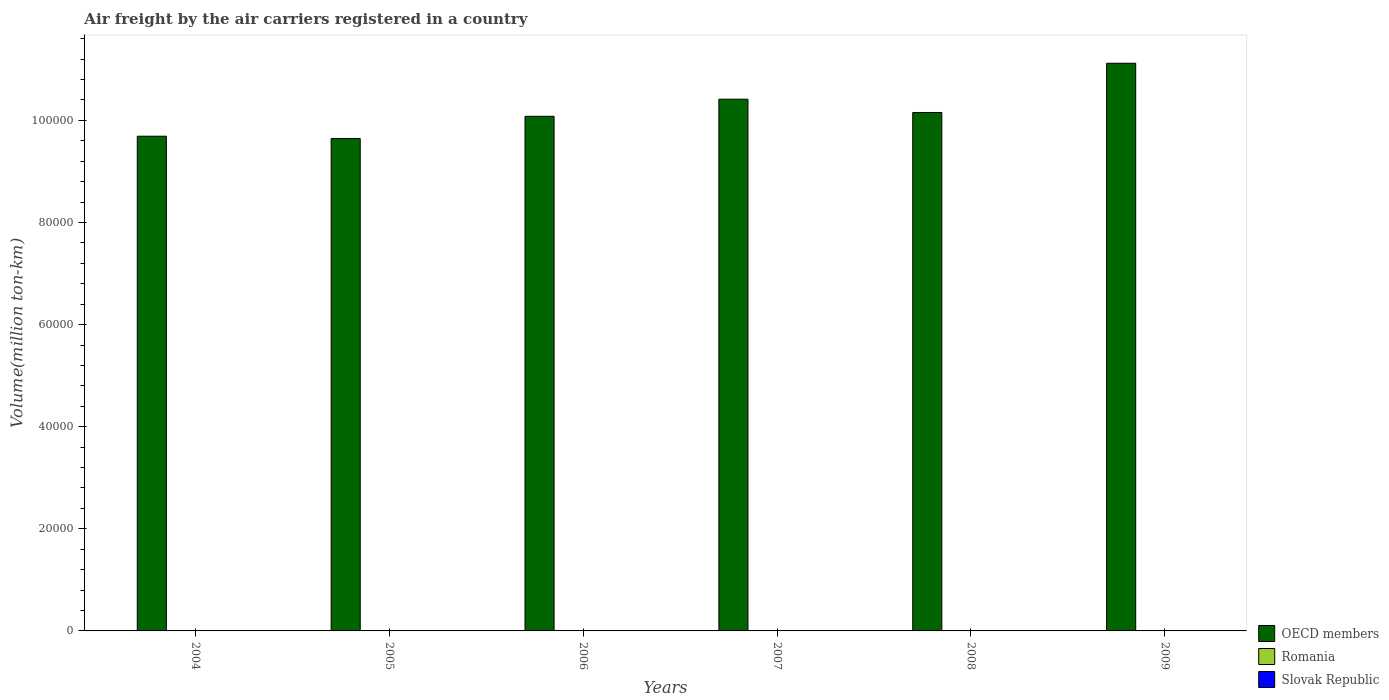How many different coloured bars are there?
Provide a short and direct response. 3. Are the number of bars per tick equal to the number of legend labels?
Offer a very short reply. Yes. How many bars are there on the 5th tick from the left?
Offer a terse response. 3. What is the label of the 3rd group of bars from the left?
Ensure brevity in your answer.  2006. In how many cases, is the number of bars for a given year not equal to the number of legend labels?
Offer a terse response. 0. What is the volume of the air carriers in Slovak Republic in 2005?
Offer a terse response. 0.32. Across all years, what is the maximum volume of the air carriers in Slovak Republic?
Offer a terse response. 45.91. Across all years, what is the minimum volume of the air carriers in Romania?
Make the answer very short. 3.99. What is the total volume of the air carriers in Romania in the graph?
Your response must be concise. 31.12. What is the difference between the volume of the air carriers in Romania in 2004 and that in 2007?
Give a very brief answer. -0.8. What is the difference between the volume of the air carriers in OECD members in 2008 and the volume of the air carriers in Romania in 2006?
Make the answer very short. 1.02e+05. What is the average volume of the air carriers in Slovak Republic per year?
Give a very brief answer. 15.46. In the year 2007, what is the difference between the volume of the air carriers in Romania and volume of the air carriers in OECD members?
Offer a very short reply. -1.04e+05. What is the ratio of the volume of the air carriers in OECD members in 2007 to that in 2009?
Provide a succinct answer. 0.94. What is the difference between the highest and the second highest volume of the air carriers in Romania?
Provide a short and direct response. 0.74. What is the difference between the highest and the lowest volume of the air carriers in OECD members?
Give a very brief answer. 1.47e+04. In how many years, is the volume of the air carriers in Slovak Republic greater than the average volume of the air carriers in Slovak Republic taken over all years?
Provide a short and direct response. 2. What does the 2nd bar from the left in 2009 represents?
Offer a very short reply. Romania. How many years are there in the graph?
Offer a very short reply. 6. Are the values on the major ticks of Y-axis written in scientific E-notation?
Keep it short and to the point. No. Does the graph contain any zero values?
Offer a terse response. No. Does the graph contain grids?
Provide a succinct answer. No. Where does the legend appear in the graph?
Offer a terse response. Bottom right. How many legend labels are there?
Make the answer very short. 3. How are the legend labels stacked?
Make the answer very short. Vertical. What is the title of the graph?
Offer a very short reply. Air freight by the air carriers registered in a country. What is the label or title of the Y-axis?
Your answer should be compact. Volume(million ton-km). What is the Volume(million ton-km) of OECD members in 2004?
Offer a terse response. 9.69e+04. What is the Volume(million ton-km) of Romania in 2004?
Keep it short and to the point. 4.88. What is the Volume(million ton-km) of Slovak Republic in 2004?
Offer a very short reply. 0.5. What is the Volume(million ton-km) in OECD members in 2005?
Your answer should be compact. 9.65e+04. What is the Volume(million ton-km) in Romania in 2005?
Keep it short and to the point. 5.16. What is the Volume(million ton-km) in Slovak Republic in 2005?
Your answer should be very brief. 0.32. What is the Volume(million ton-km) in OECD members in 2006?
Give a very brief answer. 1.01e+05. What is the Volume(million ton-km) in Romania in 2006?
Provide a short and direct response. 4.98. What is the Volume(million ton-km) of Slovak Republic in 2006?
Give a very brief answer. 0.3. What is the Volume(million ton-km) in OECD members in 2007?
Make the answer very short. 1.04e+05. What is the Volume(million ton-km) in Romania in 2007?
Make the answer very short. 5.68. What is the Volume(million ton-km) of Slovak Republic in 2007?
Provide a short and direct response. 45.48. What is the Volume(million ton-km) of OECD members in 2008?
Ensure brevity in your answer.  1.02e+05. What is the Volume(million ton-km) in Romania in 2008?
Keep it short and to the point. 6.42. What is the Volume(million ton-km) in Slovak Republic in 2008?
Keep it short and to the point. 45.91. What is the Volume(million ton-km) of OECD members in 2009?
Keep it short and to the point. 1.11e+05. What is the Volume(million ton-km) of Romania in 2009?
Give a very brief answer. 3.99. What is the Volume(million ton-km) in Slovak Republic in 2009?
Provide a short and direct response. 0.23. Across all years, what is the maximum Volume(million ton-km) in OECD members?
Offer a terse response. 1.11e+05. Across all years, what is the maximum Volume(million ton-km) of Romania?
Offer a very short reply. 6.42. Across all years, what is the maximum Volume(million ton-km) of Slovak Republic?
Offer a very short reply. 45.91. Across all years, what is the minimum Volume(million ton-km) of OECD members?
Your answer should be very brief. 9.65e+04. Across all years, what is the minimum Volume(million ton-km) in Romania?
Your answer should be very brief. 3.99. Across all years, what is the minimum Volume(million ton-km) of Slovak Republic?
Make the answer very short. 0.23. What is the total Volume(million ton-km) in OECD members in the graph?
Keep it short and to the point. 6.11e+05. What is the total Volume(million ton-km) in Romania in the graph?
Ensure brevity in your answer.  31.12. What is the total Volume(million ton-km) in Slovak Republic in the graph?
Provide a succinct answer. 92.74. What is the difference between the Volume(million ton-km) in OECD members in 2004 and that in 2005?
Keep it short and to the point. 447.78. What is the difference between the Volume(million ton-km) of Romania in 2004 and that in 2005?
Provide a succinct answer. -0.28. What is the difference between the Volume(million ton-km) in Slovak Republic in 2004 and that in 2005?
Offer a terse response. 0.19. What is the difference between the Volume(million ton-km) in OECD members in 2004 and that in 2006?
Your answer should be compact. -3902.39. What is the difference between the Volume(million ton-km) of Romania in 2004 and that in 2006?
Keep it short and to the point. -0.1. What is the difference between the Volume(million ton-km) of Slovak Republic in 2004 and that in 2006?
Your response must be concise. 0.2. What is the difference between the Volume(million ton-km) of OECD members in 2004 and that in 2007?
Provide a succinct answer. -7248.76. What is the difference between the Volume(million ton-km) of Romania in 2004 and that in 2007?
Your answer should be compact. -0.8. What is the difference between the Volume(million ton-km) in Slovak Republic in 2004 and that in 2007?
Provide a short and direct response. -44.98. What is the difference between the Volume(million ton-km) of OECD members in 2004 and that in 2008?
Give a very brief answer. -4643.08. What is the difference between the Volume(million ton-km) of Romania in 2004 and that in 2008?
Make the answer very short. -1.54. What is the difference between the Volume(million ton-km) in Slovak Republic in 2004 and that in 2008?
Offer a terse response. -45.41. What is the difference between the Volume(million ton-km) in OECD members in 2004 and that in 2009?
Ensure brevity in your answer.  -1.43e+04. What is the difference between the Volume(million ton-km) in Romania in 2004 and that in 2009?
Provide a succinct answer. 0.89. What is the difference between the Volume(million ton-km) of Slovak Republic in 2004 and that in 2009?
Offer a terse response. 0.28. What is the difference between the Volume(million ton-km) of OECD members in 2005 and that in 2006?
Provide a succinct answer. -4350.16. What is the difference between the Volume(million ton-km) of Romania in 2005 and that in 2006?
Offer a terse response. 0.18. What is the difference between the Volume(million ton-km) of Slovak Republic in 2005 and that in 2006?
Your answer should be compact. 0.01. What is the difference between the Volume(million ton-km) of OECD members in 2005 and that in 2007?
Your answer should be compact. -7696.53. What is the difference between the Volume(million ton-km) in Romania in 2005 and that in 2007?
Your answer should be compact. -0.52. What is the difference between the Volume(million ton-km) of Slovak Republic in 2005 and that in 2007?
Make the answer very short. -45.17. What is the difference between the Volume(million ton-km) in OECD members in 2005 and that in 2008?
Provide a succinct answer. -5090.85. What is the difference between the Volume(million ton-km) of Romania in 2005 and that in 2008?
Keep it short and to the point. -1.26. What is the difference between the Volume(million ton-km) in Slovak Republic in 2005 and that in 2008?
Your answer should be very brief. -45.59. What is the difference between the Volume(million ton-km) of OECD members in 2005 and that in 2009?
Offer a very short reply. -1.47e+04. What is the difference between the Volume(million ton-km) in Romania in 2005 and that in 2009?
Your response must be concise. 1.17. What is the difference between the Volume(million ton-km) of Slovak Republic in 2005 and that in 2009?
Your answer should be very brief. 0.09. What is the difference between the Volume(million ton-km) in OECD members in 2006 and that in 2007?
Your answer should be compact. -3346.37. What is the difference between the Volume(million ton-km) of Slovak Republic in 2006 and that in 2007?
Your answer should be very brief. -45.18. What is the difference between the Volume(million ton-km) of OECD members in 2006 and that in 2008?
Provide a succinct answer. -740.69. What is the difference between the Volume(million ton-km) in Romania in 2006 and that in 2008?
Your answer should be compact. -1.44. What is the difference between the Volume(million ton-km) of Slovak Republic in 2006 and that in 2008?
Provide a succinct answer. -45.61. What is the difference between the Volume(million ton-km) in OECD members in 2006 and that in 2009?
Provide a short and direct response. -1.04e+04. What is the difference between the Volume(million ton-km) of Slovak Republic in 2006 and that in 2009?
Keep it short and to the point. 0.08. What is the difference between the Volume(million ton-km) of OECD members in 2007 and that in 2008?
Provide a succinct answer. 2605.68. What is the difference between the Volume(million ton-km) of Romania in 2007 and that in 2008?
Provide a short and direct response. -0.74. What is the difference between the Volume(million ton-km) of Slovak Republic in 2007 and that in 2008?
Make the answer very short. -0.42. What is the difference between the Volume(million ton-km) in OECD members in 2007 and that in 2009?
Give a very brief answer. -7039.77. What is the difference between the Volume(million ton-km) in Romania in 2007 and that in 2009?
Give a very brief answer. 1.7. What is the difference between the Volume(million ton-km) of Slovak Republic in 2007 and that in 2009?
Your answer should be very brief. 45.26. What is the difference between the Volume(million ton-km) in OECD members in 2008 and that in 2009?
Ensure brevity in your answer.  -9645.46. What is the difference between the Volume(million ton-km) in Romania in 2008 and that in 2009?
Give a very brief answer. 2.43. What is the difference between the Volume(million ton-km) in Slovak Republic in 2008 and that in 2009?
Give a very brief answer. 45.69. What is the difference between the Volume(million ton-km) in OECD members in 2004 and the Volume(million ton-km) in Romania in 2005?
Make the answer very short. 9.69e+04. What is the difference between the Volume(million ton-km) in OECD members in 2004 and the Volume(million ton-km) in Slovak Republic in 2005?
Your response must be concise. 9.69e+04. What is the difference between the Volume(million ton-km) in Romania in 2004 and the Volume(million ton-km) in Slovak Republic in 2005?
Make the answer very short. 4.56. What is the difference between the Volume(million ton-km) in OECD members in 2004 and the Volume(million ton-km) in Romania in 2006?
Offer a terse response. 9.69e+04. What is the difference between the Volume(million ton-km) in OECD members in 2004 and the Volume(million ton-km) in Slovak Republic in 2006?
Ensure brevity in your answer.  9.69e+04. What is the difference between the Volume(million ton-km) in Romania in 2004 and the Volume(million ton-km) in Slovak Republic in 2006?
Your answer should be compact. 4.58. What is the difference between the Volume(million ton-km) in OECD members in 2004 and the Volume(million ton-km) in Romania in 2007?
Keep it short and to the point. 9.69e+04. What is the difference between the Volume(million ton-km) of OECD members in 2004 and the Volume(million ton-km) of Slovak Republic in 2007?
Offer a very short reply. 9.69e+04. What is the difference between the Volume(million ton-km) in Romania in 2004 and the Volume(million ton-km) in Slovak Republic in 2007?
Your response must be concise. -40.6. What is the difference between the Volume(million ton-km) in OECD members in 2004 and the Volume(million ton-km) in Romania in 2008?
Ensure brevity in your answer.  9.69e+04. What is the difference between the Volume(million ton-km) of OECD members in 2004 and the Volume(million ton-km) of Slovak Republic in 2008?
Keep it short and to the point. 9.69e+04. What is the difference between the Volume(million ton-km) in Romania in 2004 and the Volume(million ton-km) in Slovak Republic in 2008?
Your response must be concise. -41.03. What is the difference between the Volume(million ton-km) in OECD members in 2004 and the Volume(million ton-km) in Romania in 2009?
Ensure brevity in your answer.  9.69e+04. What is the difference between the Volume(million ton-km) in OECD members in 2004 and the Volume(million ton-km) in Slovak Republic in 2009?
Offer a very short reply. 9.69e+04. What is the difference between the Volume(million ton-km) in Romania in 2004 and the Volume(million ton-km) in Slovak Republic in 2009?
Your response must be concise. 4.66. What is the difference between the Volume(million ton-km) of OECD members in 2005 and the Volume(million ton-km) of Romania in 2006?
Provide a short and direct response. 9.65e+04. What is the difference between the Volume(million ton-km) of OECD members in 2005 and the Volume(million ton-km) of Slovak Republic in 2006?
Provide a succinct answer. 9.65e+04. What is the difference between the Volume(million ton-km) of Romania in 2005 and the Volume(million ton-km) of Slovak Republic in 2006?
Ensure brevity in your answer.  4.86. What is the difference between the Volume(million ton-km) of OECD members in 2005 and the Volume(million ton-km) of Romania in 2007?
Offer a terse response. 9.65e+04. What is the difference between the Volume(million ton-km) in OECD members in 2005 and the Volume(million ton-km) in Slovak Republic in 2007?
Your answer should be compact. 9.64e+04. What is the difference between the Volume(million ton-km) of Romania in 2005 and the Volume(million ton-km) of Slovak Republic in 2007?
Provide a succinct answer. -40.32. What is the difference between the Volume(million ton-km) of OECD members in 2005 and the Volume(million ton-km) of Romania in 2008?
Make the answer very short. 9.65e+04. What is the difference between the Volume(million ton-km) of OECD members in 2005 and the Volume(million ton-km) of Slovak Republic in 2008?
Your answer should be compact. 9.64e+04. What is the difference between the Volume(million ton-km) of Romania in 2005 and the Volume(million ton-km) of Slovak Republic in 2008?
Your answer should be very brief. -40.75. What is the difference between the Volume(million ton-km) of OECD members in 2005 and the Volume(million ton-km) of Romania in 2009?
Offer a terse response. 9.65e+04. What is the difference between the Volume(million ton-km) in OECD members in 2005 and the Volume(million ton-km) in Slovak Republic in 2009?
Your response must be concise. 9.65e+04. What is the difference between the Volume(million ton-km) of Romania in 2005 and the Volume(million ton-km) of Slovak Republic in 2009?
Provide a succinct answer. 4.94. What is the difference between the Volume(million ton-km) of OECD members in 2006 and the Volume(million ton-km) of Romania in 2007?
Offer a terse response. 1.01e+05. What is the difference between the Volume(million ton-km) of OECD members in 2006 and the Volume(million ton-km) of Slovak Republic in 2007?
Your answer should be compact. 1.01e+05. What is the difference between the Volume(million ton-km) of Romania in 2006 and the Volume(million ton-km) of Slovak Republic in 2007?
Provide a succinct answer. -40.5. What is the difference between the Volume(million ton-km) in OECD members in 2006 and the Volume(million ton-km) in Romania in 2008?
Your response must be concise. 1.01e+05. What is the difference between the Volume(million ton-km) of OECD members in 2006 and the Volume(million ton-km) of Slovak Republic in 2008?
Your answer should be compact. 1.01e+05. What is the difference between the Volume(million ton-km) of Romania in 2006 and the Volume(million ton-km) of Slovak Republic in 2008?
Ensure brevity in your answer.  -40.93. What is the difference between the Volume(million ton-km) of OECD members in 2006 and the Volume(million ton-km) of Romania in 2009?
Provide a short and direct response. 1.01e+05. What is the difference between the Volume(million ton-km) of OECD members in 2006 and the Volume(million ton-km) of Slovak Republic in 2009?
Your answer should be compact. 1.01e+05. What is the difference between the Volume(million ton-km) in Romania in 2006 and the Volume(million ton-km) in Slovak Republic in 2009?
Offer a very short reply. 4.76. What is the difference between the Volume(million ton-km) in OECD members in 2007 and the Volume(million ton-km) in Romania in 2008?
Keep it short and to the point. 1.04e+05. What is the difference between the Volume(million ton-km) of OECD members in 2007 and the Volume(million ton-km) of Slovak Republic in 2008?
Your answer should be very brief. 1.04e+05. What is the difference between the Volume(million ton-km) of Romania in 2007 and the Volume(million ton-km) of Slovak Republic in 2008?
Make the answer very short. -40.23. What is the difference between the Volume(million ton-km) of OECD members in 2007 and the Volume(million ton-km) of Romania in 2009?
Offer a very short reply. 1.04e+05. What is the difference between the Volume(million ton-km) of OECD members in 2007 and the Volume(million ton-km) of Slovak Republic in 2009?
Provide a short and direct response. 1.04e+05. What is the difference between the Volume(million ton-km) of Romania in 2007 and the Volume(million ton-km) of Slovak Republic in 2009?
Keep it short and to the point. 5.46. What is the difference between the Volume(million ton-km) of OECD members in 2008 and the Volume(million ton-km) of Romania in 2009?
Your answer should be compact. 1.02e+05. What is the difference between the Volume(million ton-km) of OECD members in 2008 and the Volume(million ton-km) of Slovak Republic in 2009?
Provide a short and direct response. 1.02e+05. What is the difference between the Volume(million ton-km) of Romania in 2008 and the Volume(million ton-km) of Slovak Republic in 2009?
Provide a short and direct response. 6.2. What is the average Volume(million ton-km) of OECD members per year?
Provide a short and direct response. 1.02e+05. What is the average Volume(million ton-km) in Romania per year?
Your answer should be very brief. 5.19. What is the average Volume(million ton-km) in Slovak Republic per year?
Ensure brevity in your answer.  15.46. In the year 2004, what is the difference between the Volume(million ton-km) in OECD members and Volume(million ton-km) in Romania?
Make the answer very short. 9.69e+04. In the year 2004, what is the difference between the Volume(million ton-km) in OECD members and Volume(million ton-km) in Slovak Republic?
Offer a very short reply. 9.69e+04. In the year 2004, what is the difference between the Volume(million ton-km) of Romania and Volume(million ton-km) of Slovak Republic?
Give a very brief answer. 4.38. In the year 2005, what is the difference between the Volume(million ton-km) of OECD members and Volume(million ton-km) of Romania?
Provide a short and direct response. 9.65e+04. In the year 2005, what is the difference between the Volume(million ton-km) in OECD members and Volume(million ton-km) in Slovak Republic?
Ensure brevity in your answer.  9.65e+04. In the year 2005, what is the difference between the Volume(million ton-km) of Romania and Volume(million ton-km) of Slovak Republic?
Ensure brevity in your answer.  4.84. In the year 2006, what is the difference between the Volume(million ton-km) in OECD members and Volume(million ton-km) in Romania?
Ensure brevity in your answer.  1.01e+05. In the year 2006, what is the difference between the Volume(million ton-km) of OECD members and Volume(million ton-km) of Slovak Republic?
Your answer should be very brief. 1.01e+05. In the year 2006, what is the difference between the Volume(million ton-km) in Romania and Volume(million ton-km) in Slovak Republic?
Your answer should be very brief. 4.68. In the year 2007, what is the difference between the Volume(million ton-km) of OECD members and Volume(million ton-km) of Romania?
Keep it short and to the point. 1.04e+05. In the year 2007, what is the difference between the Volume(million ton-km) of OECD members and Volume(million ton-km) of Slovak Republic?
Provide a short and direct response. 1.04e+05. In the year 2007, what is the difference between the Volume(million ton-km) of Romania and Volume(million ton-km) of Slovak Republic?
Keep it short and to the point. -39.8. In the year 2008, what is the difference between the Volume(million ton-km) of OECD members and Volume(million ton-km) of Romania?
Ensure brevity in your answer.  1.02e+05. In the year 2008, what is the difference between the Volume(million ton-km) of OECD members and Volume(million ton-km) of Slovak Republic?
Keep it short and to the point. 1.02e+05. In the year 2008, what is the difference between the Volume(million ton-km) in Romania and Volume(million ton-km) in Slovak Republic?
Provide a short and direct response. -39.49. In the year 2009, what is the difference between the Volume(million ton-km) in OECD members and Volume(million ton-km) in Romania?
Ensure brevity in your answer.  1.11e+05. In the year 2009, what is the difference between the Volume(million ton-km) of OECD members and Volume(million ton-km) of Slovak Republic?
Provide a succinct answer. 1.11e+05. In the year 2009, what is the difference between the Volume(million ton-km) of Romania and Volume(million ton-km) of Slovak Republic?
Offer a very short reply. 3.76. What is the ratio of the Volume(million ton-km) in Romania in 2004 to that in 2005?
Provide a short and direct response. 0.95. What is the ratio of the Volume(million ton-km) in Slovak Republic in 2004 to that in 2005?
Provide a succinct answer. 1.59. What is the ratio of the Volume(million ton-km) in OECD members in 2004 to that in 2006?
Make the answer very short. 0.96. What is the ratio of the Volume(million ton-km) of Romania in 2004 to that in 2006?
Offer a terse response. 0.98. What is the ratio of the Volume(million ton-km) in Slovak Republic in 2004 to that in 2006?
Ensure brevity in your answer.  1.67. What is the ratio of the Volume(million ton-km) of OECD members in 2004 to that in 2007?
Make the answer very short. 0.93. What is the ratio of the Volume(million ton-km) of Romania in 2004 to that in 2007?
Offer a very short reply. 0.86. What is the ratio of the Volume(million ton-km) of Slovak Republic in 2004 to that in 2007?
Offer a terse response. 0.01. What is the ratio of the Volume(million ton-km) of OECD members in 2004 to that in 2008?
Provide a short and direct response. 0.95. What is the ratio of the Volume(million ton-km) in Romania in 2004 to that in 2008?
Your answer should be very brief. 0.76. What is the ratio of the Volume(million ton-km) of Slovak Republic in 2004 to that in 2008?
Provide a succinct answer. 0.01. What is the ratio of the Volume(million ton-km) of OECD members in 2004 to that in 2009?
Provide a short and direct response. 0.87. What is the ratio of the Volume(million ton-km) of Romania in 2004 to that in 2009?
Your answer should be very brief. 1.22. What is the ratio of the Volume(million ton-km) in Slovak Republic in 2004 to that in 2009?
Make the answer very short. 2.24. What is the ratio of the Volume(million ton-km) of OECD members in 2005 to that in 2006?
Make the answer very short. 0.96. What is the ratio of the Volume(million ton-km) in Romania in 2005 to that in 2006?
Your answer should be compact. 1.04. What is the ratio of the Volume(million ton-km) of Slovak Republic in 2005 to that in 2006?
Your response must be concise. 1.05. What is the ratio of the Volume(million ton-km) in OECD members in 2005 to that in 2007?
Provide a short and direct response. 0.93. What is the ratio of the Volume(million ton-km) in Romania in 2005 to that in 2007?
Offer a terse response. 0.91. What is the ratio of the Volume(million ton-km) of Slovak Republic in 2005 to that in 2007?
Your response must be concise. 0.01. What is the ratio of the Volume(million ton-km) of OECD members in 2005 to that in 2008?
Make the answer very short. 0.95. What is the ratio of the Volume(million ton-km) in Romania in 2005 to that in 2008?
Your response must be concise. 0.8. What is the ratio of the Volume(million ton-km) in Slovak Republic in 2005 to that in 2008?
Your answer should be compact. 0.01. What is the ratio of the Volume(million ton-km) in OECD members in 2005 to that in 2009?
Give a very brief answer. 0.87. What is the ratio of the Volume(million ton-km) in Romania in 2005 to that in 2009?
Keep it short and to the point. 1.29. What is the ratio of the Volume(million ton-km) in Slovak Republic in 2005 to that in 2009?
Your answer should be very brief. 1.41. What is the ratio of the Volume(million ton-km) of OECD members in 2006 to that in 2007?
Offer a very short reply. 0.97. What is the ratio of the Volume(million ton-km) of Romania in 2006 to that in 2007?
Offer a very short reply. 0.88. What is the ratio of the Volume(million ton-km) in Slovak Republic in 2006 to that in 2007?
Make the answer very short. 0.01. What is the ratio of the Volume(million ton-km) of OECD members in 2006 to that in 2008?
Keep it short and to the point. 0.99. What is the ratio of the Volume(million ton-km) of Romania in 2006 to that in 2008?
Your response must be concise. 0.78. What is the ratio of the Volume(million ton-km) in Slovak Republic in 2006 to that in 2008?
Provide a short and direct response. 0.01. What is the ratio of the Volume(million ton-km) of OECD members in 2006 to that in 2009?
Provide a succinct answer. 0.91. What is the ratio of the Volume(million ton-km) of Romania in 2006 to that in 2009?
Ensure brevity in your answer.  1.25. What is the ratio of the Volume(million ton-km) of Slovak Republic in 2006 to that in 2009?
Give a very brief answer. 1.34. What is the ratio of the Volume(million ton-km) in OECD members in 2007 to that in 2008?
Provide a succinct answer. 1.03. What is the ratio of the Volume(million ton-km) in Romania in 2007 to that in 2008?
Ensure brevity in your answer.  0.89. What is the ratio of the Volume(million ton-km) in OECD members in 2007 to that in 2009?
Keep it short and to the point. 0.94. What is the ratio of the Volume(million ton-km) in Romania in 2007 to that in 2009?
Give a very brief answer. 1.43. What is the ratio of the Volume(million ton-km) of Slovak Republic in 2007 to that in 2009?
Your response must be concise. 202.16. What is the ratio of the Volume(million ton-km) of OECD members in 2008 to that in 2009?
Give a very brief answer. 0.91. What is the ratio of the Volume(million ton-km) in Romania in 2008 to that in 2009?
Offer a terse response. 1.61. What is the ratio of the Volume(million ton-km) in Slovak Republic in 2008 to that in 2009?
Your answer should be very brief. 204.04. What is the difference between the highest and the second highest Volume(million ton-km) of OECD members?
Make the answer very short. 7039.77. What is the difference between the highest and the second highest Volume(million ton-km) of Romania?
Provide a short and direct response. 0.74. What is the difference between the highest and the second highest Volume(million ton-km) of Slovak Republic?
Provide a short and direct response. 0.42. What is the difference between the highest and the lowest Volume(million ton-km) in OECD members?
Offer a terse response. 1.47e+04. What is the difference between the highest and the lowest Volume(million ton-km) of Romania?
Give a very brief answer. 2.43. What is the difference between the highest and the lowest Volume(million ton-km) of Slovak Republic?
Provide a succinct answer. 45.69. 